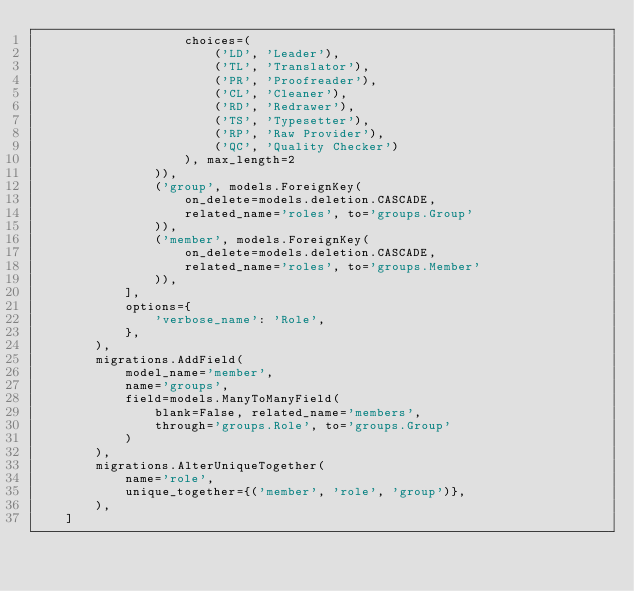<code> <loc_0><loc_0><loc_500><loc_500><_Python_>                    choices=(
                        ('LD', 'Leader'),
                        ('TL', 'Translator'),
                        ('PR', 'Proofreader'),
                        ('CL', 'Cleaner'),
                        ('RD', 'Redrawer'),
                        ('TS', 'Typesetter'),
                        ('RP', 'Raw Provider'),
                        ('QC', 'Quality Checker')
                    ), max_length=2
                )),
                ('group', models.ForeignKey(
                    on_delete=models.deletion.CASCADE,
                    related_name='roles', to='groups.Group'
                )),
                ('member', models.ForeignKey(
                    on_delete=models.deletion.CASCADE,
                    related_name='roles', to='groups.Member'
                )),
            ],
            options={
                'verbose_name': 'Role',
            },
        ),
        migrations.AddField(
            model_name='member',
            name='groups',
            field=models.ManyToManyField(
                blank=False, related_name='members',
                through='groups.Role', to='groups.Group'
            )
        ),
        migrations.AlterUniqueTogether(
            name='role',
            unique_together={('member', 'role', 'group')},
        ),
    ]
</code> 